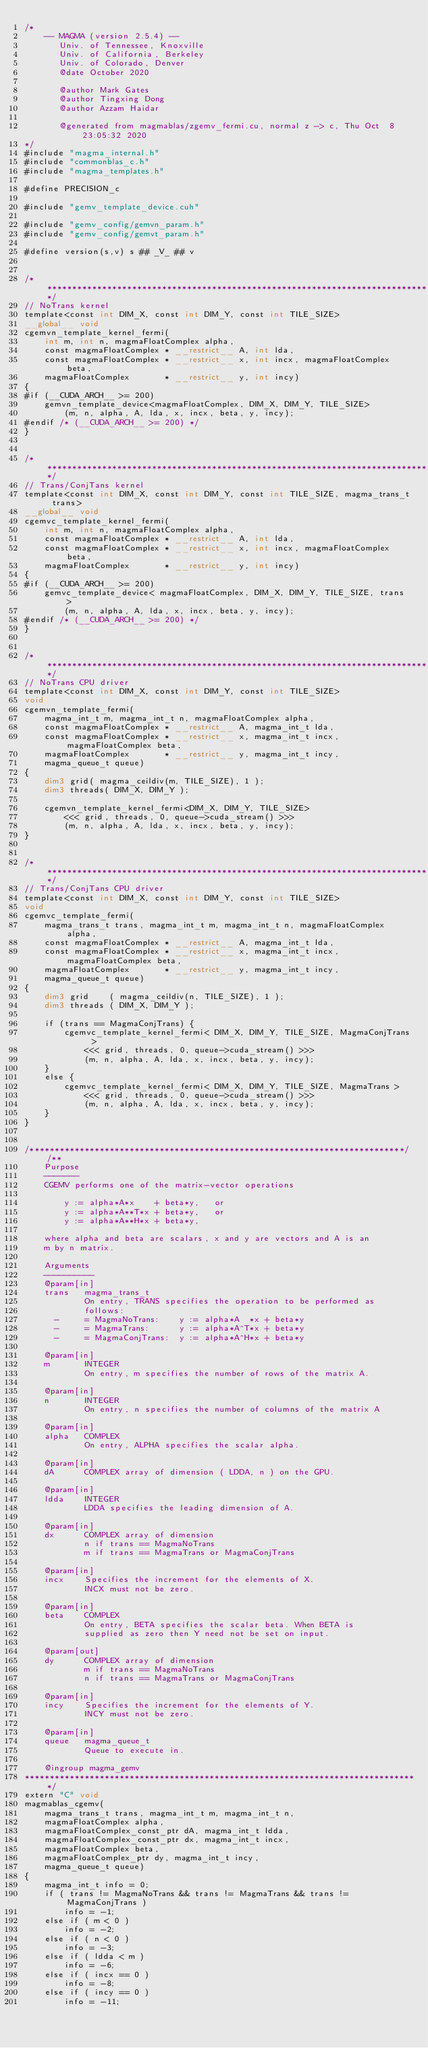<code> <loc_0><loc_0><loc_500><loc_500><_Cuda_>/*
    -- MAGMA (version 2.5.4) --
       Univ. of Tennessee, Knoxville
       Univ. of California, Berkeley
       Univ. of Colorado, Denver
       @date October 2020
       
       @author Mark Gates
       @author Tingxing Dong
       @author Azzam Haidar

       @generated from magmablas/zgemv_fermi.cu, normal z -> c, Thu Oct  8 23:05:32 2020
*/
#include "magma_internal.h"
#include "commonblas_c.h"
#include "magma_templates.h"

#define PRECISION_c

#include "gemv_template_device.cuh"

#include "gemv_config/gemvn_param.h"
#include "gemv_config/gemvt_param.h"

#define version(s,v) s ## _V_ ## v


/******************************************************************************/
// NoTrans kernel
template<const int DIM_X, const int DIM_Y, const int TILE_SIZE>
__global__ void
cgemvn_template_kernel_fermi(
    int m, int n, magmaFloatComplex alpha,
    const magmaFloatComplex * __restrict__ A, int lda,
    const magmaFloatComplex * __restrict__ x, int incx, magmaFloatComplex beta,
    magmaFloatComplex       * __restrict__ y, int incy)
{
#if (__CUDA_ARCH__ >= 200)
    gemvn_template_device<magmaFloatComplex, DIM_X, DIM_Y, TILE_SIZE>
        (m, n, alpha, A, lda, x, incx, beta, y, incy);
#endif /* (__CUDA_ARCH__ >= 200) */
}


/******************************************************************************/
// Trans/ConjTans kernel
template<const int DIM_X, const int DIM_Y, const int TILE_SIZE, magma_trans_t trans>
__global__ void
cgemvc_template_kernel_fermi(
    int m, int n, magmaFloatComplex alpha,
    const magmaFloatComplex * __restrict__ A, int lda,
    const magmaFloatComplex * __restrict__ x, int incx, magmaFloatComplex beta,
    magmaFloatComplex       * __restrict__ y, int incy)
{
#if (__CUDA_ARCH__ >= 200)
    gemvc_template_device< magmaFloatComplex, DIM_X, DIM_Y, TILE_SIZE, trans >
        (m, n, alpha, A, lda, x, incx, beta, y, incy);
#endif /* (__CUDA_ARCH__ >= 200) */
}


/******************************************************************************/
// NoTrans CPU driver
template<const int DIM_X, const int DIM_Y, const int TILE_SIZE>
void
cgemvn_template_fermi(
    magma_int_t m, magma_int_t n, magmaFloatComplex alpha,
    const magmaFloatComplex * __restrict__ A, magma_int_t lda,
    const magmaFloatComplex * __restrict__ x, magma_int_t incx, magmaFloatComplex beta,
    magmaFloatComplex       * __restrict__ y, magma_int_t incy,
    magma_queue_t queue)
{
    dim3 grid( magma_ceildiv(m, TILE_SIZE), 1 );
    dim3 threads( DIM_X, DIM_Y );

    cgemvn_template_kernel_fermi<DIM_X, DIM_Y, TILE_SIZE>
        <<< grid, threads, 0, queue->cuda_stream() >>>
        (m, n, alpha, A, lda, x, incx, beta, y, incy);
}


/******************************************************************************/
// Trans/ConjTans CPU driver
template<const int DIM_X, const int DIM_Y, const int TILE_SIZE>
void
cgemvc_template_fermi(
    magma_trans_t trans, magma_int_t m, magma_int_t n, magmaFloatComplex alpha,
    const magmaFloatComplex * __restrict__ A, magma_int_t lda,
    const magmaFloatComplex * __restrict__ x, magma_int_t incx, magmaFloatComplex beta,
    magmaFloatComplex       * __restrict__ y, magma_int_t incy,
    magma_queue_t queue)
{
    dim3 grid    ( magma_ceildiv(n, TILE_SIZE), 1 );
    dim3 threads ( DIM_X, DIM_Y );
    
    if (trans == MagmaConjTrans) {
        cgemvc_template_kernel_fermi< DIM_X, DIM_Y, TILE_SIZE, MagmaConjTrans >
            <<< grid, threads, 0, queue->cuda_stream() >>>
            (m, n, alpha, A, lda, x, incx, beta, y, incy);
    }
    else {
        cgemvc_template_kernel_fermi< DIM_X, DIM_Y, TILE_SIZE, MagmaTrans >
            <<< grid, threads, 0, queue->cuda_stream() >>>
            (m, n, alpha, A, lda, x, incx, beta, y, incy);
    }
}


/***************************************************************************//**
    Purpose
    -------
    CGEMV performs one of the matrix-vector operations
    
        y := alpha*A*x    + beta*y,   or
        y := alpha*A**T*x + beta*y,   or
        y := alpha*A**H*x + beta*y,
    
    where alpha and beta are scalars, x and y are vectors and A is an
    m by n matrix.

    Arguments
    ----------
    @param[in]
    trans   magma_trans_t
            On entry, TRANS specifies the operation to be performed as
            follows:
      -     = MagmaNoTrans:    y := alpha*A  *x + beta*y
      -     = MagmaTrans:      y := alpha*A^T*x + beta*y
      -     = MagmaConjTrans:  y := alpha*A^H*x + beta*y

    @param[in]
    m       INTEGER
            On entry, m specifies the number of rows of the matrix A.

    @param[in]
    n       INTEGER
            On entry, n specifies the number of columns of the matrix A
 
    @param[in]
    alpha   COMPLEX
            On entry, ALPHA specifies the scalar alpha.

    @param[in]
    dA      COMPLEX array of dimension ( LDDA, n ) on the GPU.
   
    @param[in]
    ldda    INTEGER
            LDDA specifies the leading dimension of A.

    @param[in]
    dx      COMPLEX array of dimension
            n if trans == MagmaNoTrans
            m if trans == MagmaTrans or MagmaConjTrans
     
    @param[in]
    incx    Specifies the increment for the elements of X.
            INCX must not be zero.
  
    @param[in]
    beta    COMPLEX
            On entry, BETA specifies the scalar beta. When BETA is
            supplied as zero then Y need not be set on input.

    @param[out]
    dy      COMPLEX array of dimension
            m if trans == MagmaNoTrans
            n if trans == MagmaTrans or MagmaConjTrans

    @param[in]
    incy    Specifies the increment for the elements of Y.
            INCY must not be zero.

    @param[in]
    queue   magma_queue_t
            Queue to execute in.

    @ingroup magma_gemv
*******************************************************************************/
extern "C" void
magmablas_cgemv(
    magma_trans_t trans, magma_int_t m, magma_int_t n, 
    magmaFloatComplex alpha,
    magmaFloatComplex_const_ptr dA, magma_int_t ldda,
    magmaFloatComplex_const_ptr dx, magma_int_t incx,
    magmaFloatComplex beta,
    magmaFloatComplex_ptr dy, magma_int_t incy, 
    magma_queue_t queue)
{
    magma_int_t info = 0;
    if ( trans != MagmaNoTrans && trans != MagmaTrans && trans != MagmaConjTrans )
        info = -1;
    else if ( m < 0 )
        info = -2;
    else if ( n < 0 )
        info = -3;
    else if ( ldda < m )
        info = -6;
    else if ( incx == 0 )
        info = -8;
    else if ( incy == 0 )
        info = -11;
    </code> 